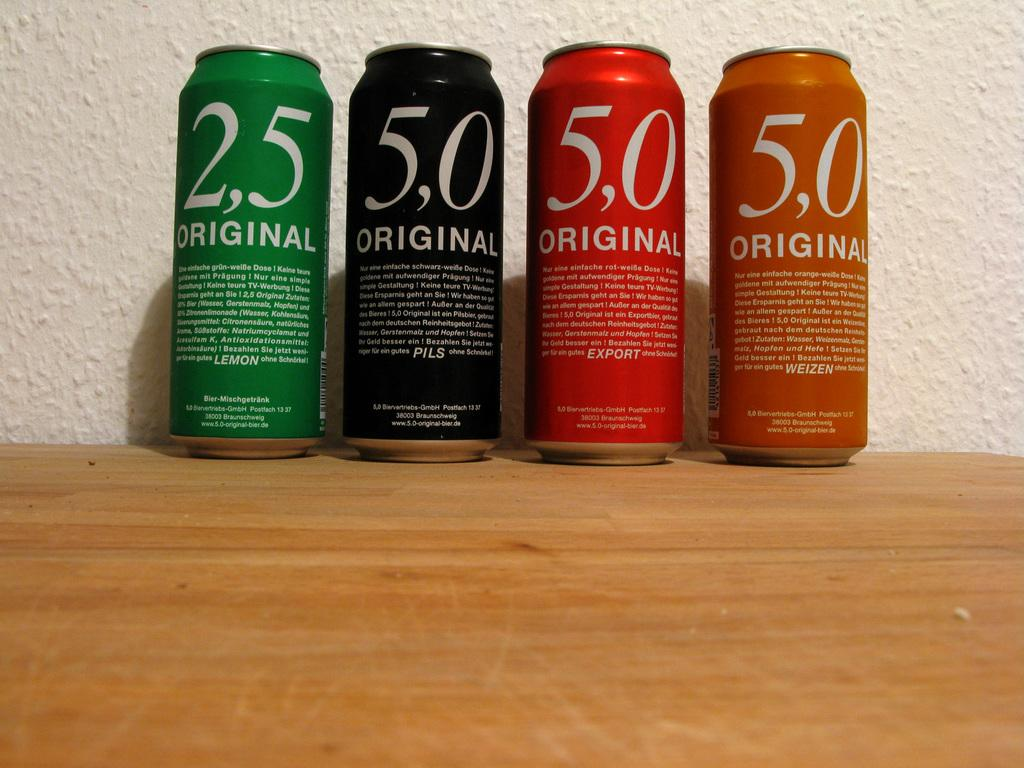<image>
Present a compact description of the photo's key features. Four different beverage cans are labeled 2,5 and 5,0 original. 